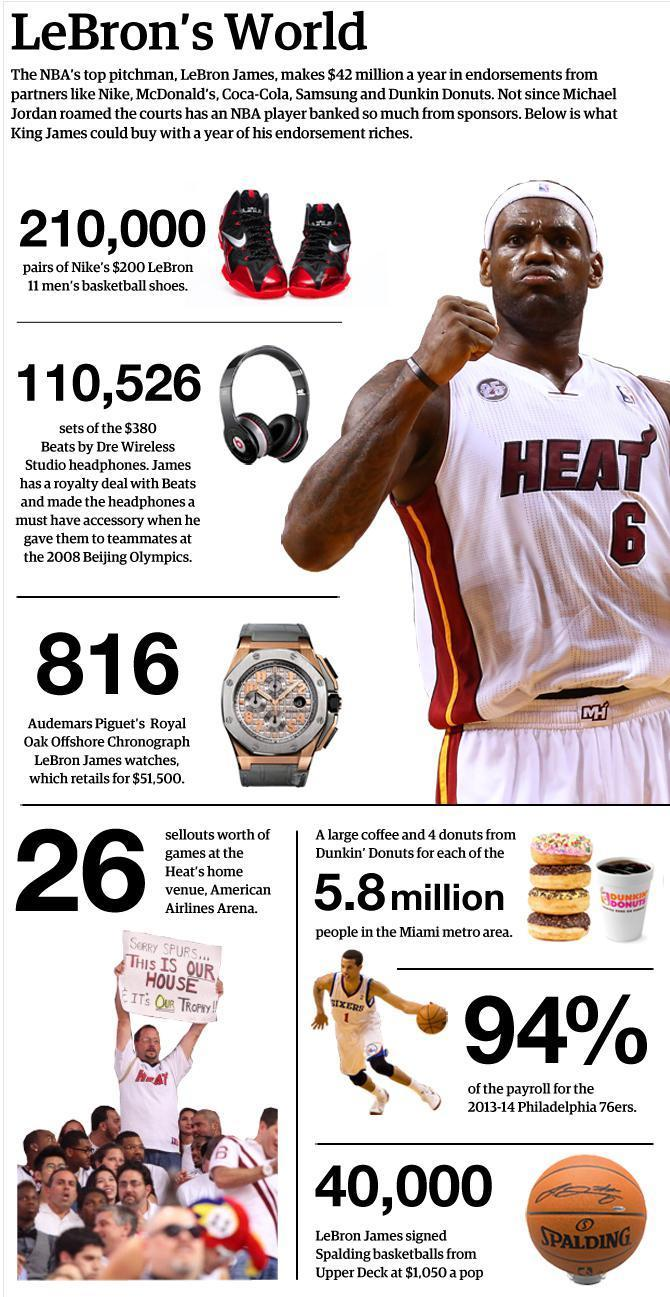How many balls are in this infographic?
Answer the question with a short phrase. 2 